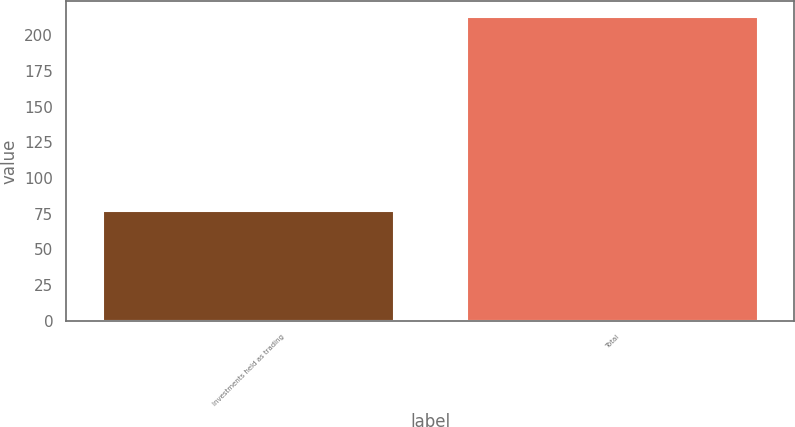Convert chart to OTSL. <chart><loc_0><loc_0><loc_500><loc_500><bar_chart><fcel>Investments held as trading<fcel>Total<nl><fcel>77.2<fcel>213.2<nl></chart> 